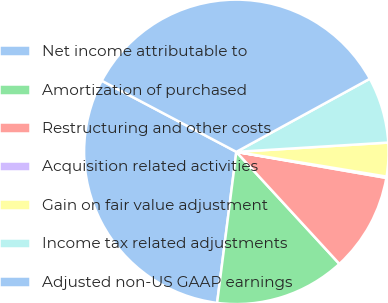<chart> <loc_0><loc_0><loc_500><loc_500><pie_chart><fcel>Net income attributable to<fcel>Amortization of purchased<fcel>Restructuring and other costs<fcel>Acquisition related activities<fcel>Gain on fair value adjustment<fcel>Income tax related adjustments<fcel>Adjusted non-US GAAP earnings<nl><fcel>30.73%<fcel>13.85%<fcel>10.43%<fcel>0.14%<fcel>3.57%<fcel>7.0%<fcel>34.29%<nl></chart> 